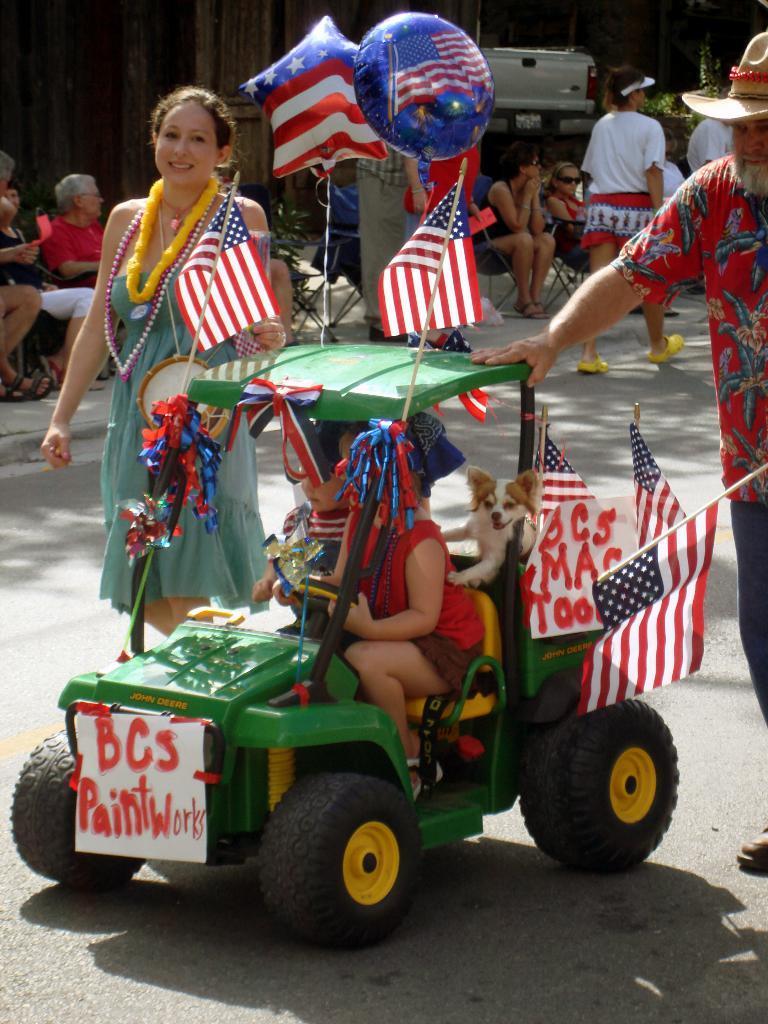Please provide a concise description of this image. In this picture I can see two kids and a dog in a vehicle, there is a paper, there are flags, there are two persons standing and holding the flags, there are balloons, and in the background there is a vehicle, group of people sitting on the chairs and two persons standing. 